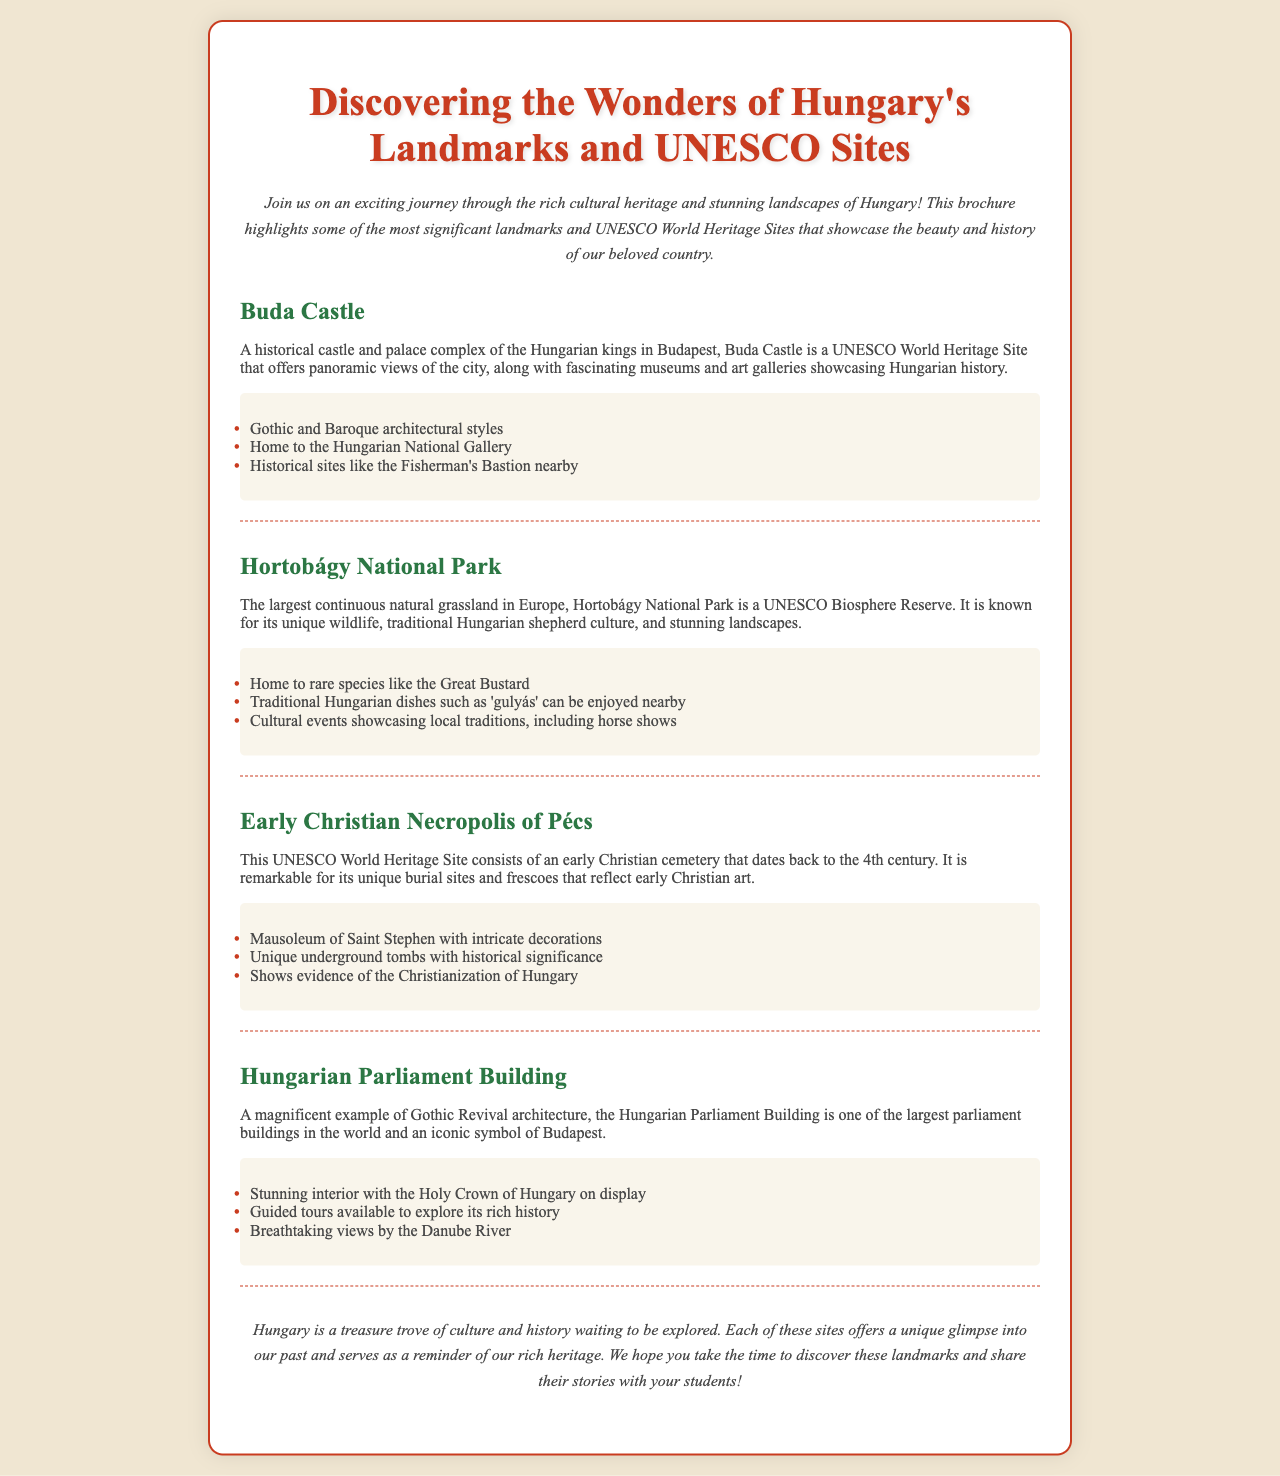What is the title of the brochure? The title of the brochure is prominently displayed at the top of the document, introducing the theme of the content.
Answer: Discovering the Wonders of Hungary's Landmarks and UNESCO Sites What city is Buda Castle located in? The document specifies that Buda Castle is a historical castle and palace complex in Budapest.
Answer: Budapest What type of architecture is the Hungarian Parliament Building an example of? The document describes the Hungarian Parliament Building as a magnificent example of Gothic Revival architecture.
Answer: Gothic Revival Which UNESCO site is known for rare species like the Great Bustard? The document highlights that Hortobágy National Park is home to rare species including the Great Bustard.
Answer: Hortobágy National Park What century does the Early Christian Necropolis of Pécs date back to? The document states that the Early Christian Necropolis of Pécs dates back to the 4th century.
Answer: 4th century What unique feature does the mausoleum of Saint Stephen have? The document mentions that the mausoleum of Saint Stephen is noteworthy for its intricate decorations.
Answer: Intricate decorations What significant cultural event is mentioned in connection with Hortobágy National Park? The document mentions cultural events showcasing local traditions, specifically horse shows.
Answer: Horse shows Which landmark showcases the Holy Crown of Hungary? The document indicates that the Hungarian Parliament Building displays the Holy Crown of Hungary inside.
Answer: Hungarian Parliament Building 